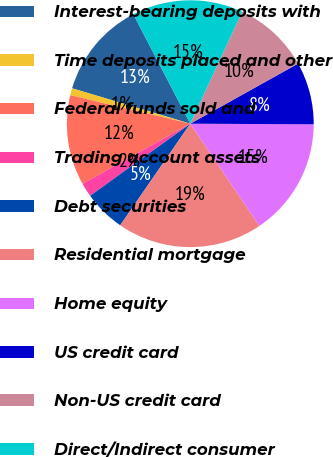Convert chart to OTSL. <chart><loc_0><loc_0><loc_500><loc_500><pie_chart><fcel>Interest-bearing deposits with<fcel>Time deposits placed and other<fcel>Federal funds sold and<fcel>Trading account assets<fcel>Debt securities<fcel>Residential mortgage<fcel>Home equity<fcel>US credit card<fcel>Non-US credit card<fcel>Direct/Indirect consumer<nl><fcel>12.73%<fcel>0.92%<fcel>11.82%<fcel>1.82%<fcel>5.46%<fcel>19.08%<fcel>15.45%<fcel>8.18%<fcel>10.0%<fcel>14.54%<nl></chart> 